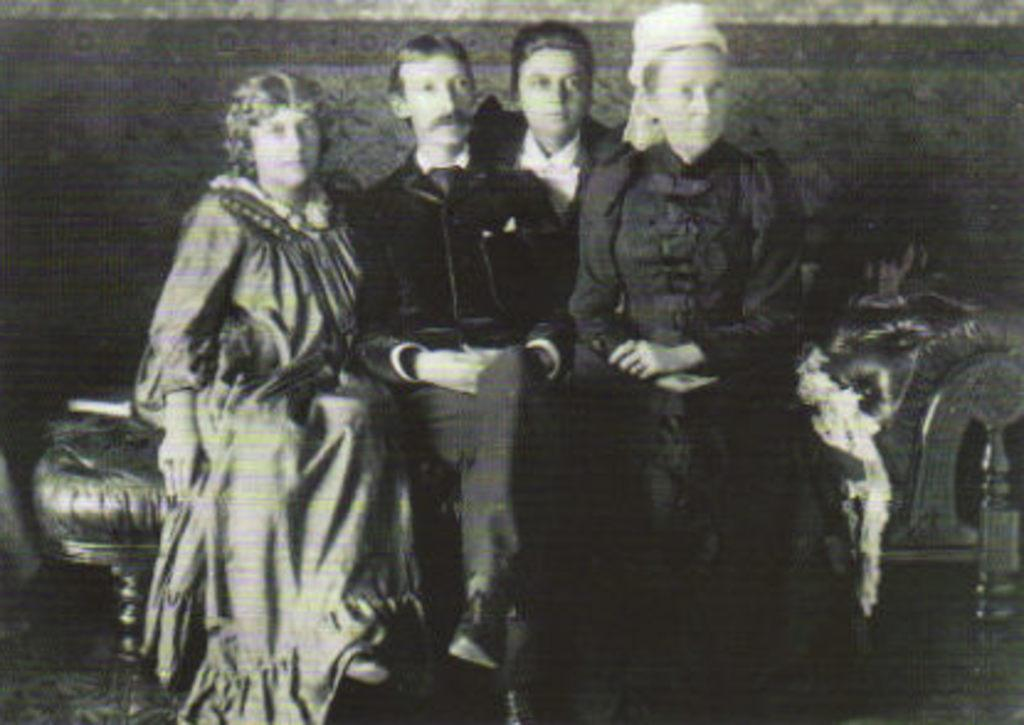What is the color scheme of the image? The image is black and white. What can be seen in the center of the image? There are four people sitting on a couch in the center of the image. What type of wilderness can be seen in the background of the image? There is no wilderness visible in the image, as mentioned, the image is black and white. What kind of dinner is being served in the image? There is no dinner being served in the image. 